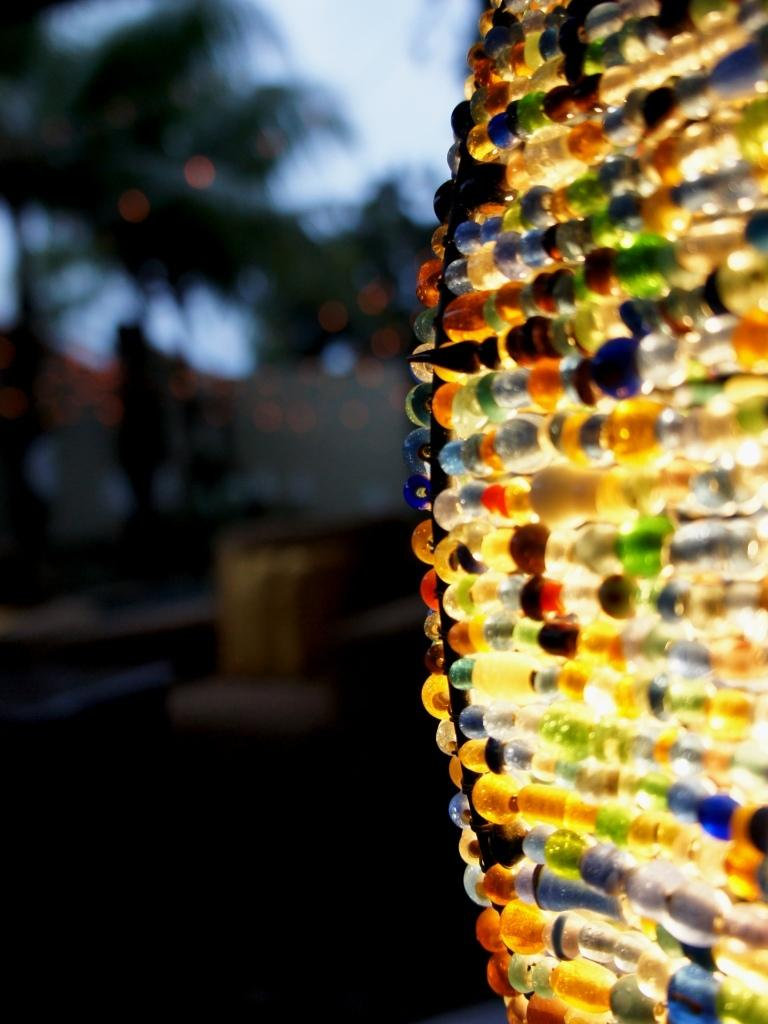What types of objects can be seen in the image? There are decorative items in the image. What can be seen in the background of the image? There are trees and the sky visible in the background of the image. What type of impulse can be seen affecting the decorative items in the image? There is no impulse affecting the decorative items in the image; they are stationary. Can you see an airplane flying in the sky in the image? There is no airplane visible in the sky in the image. 